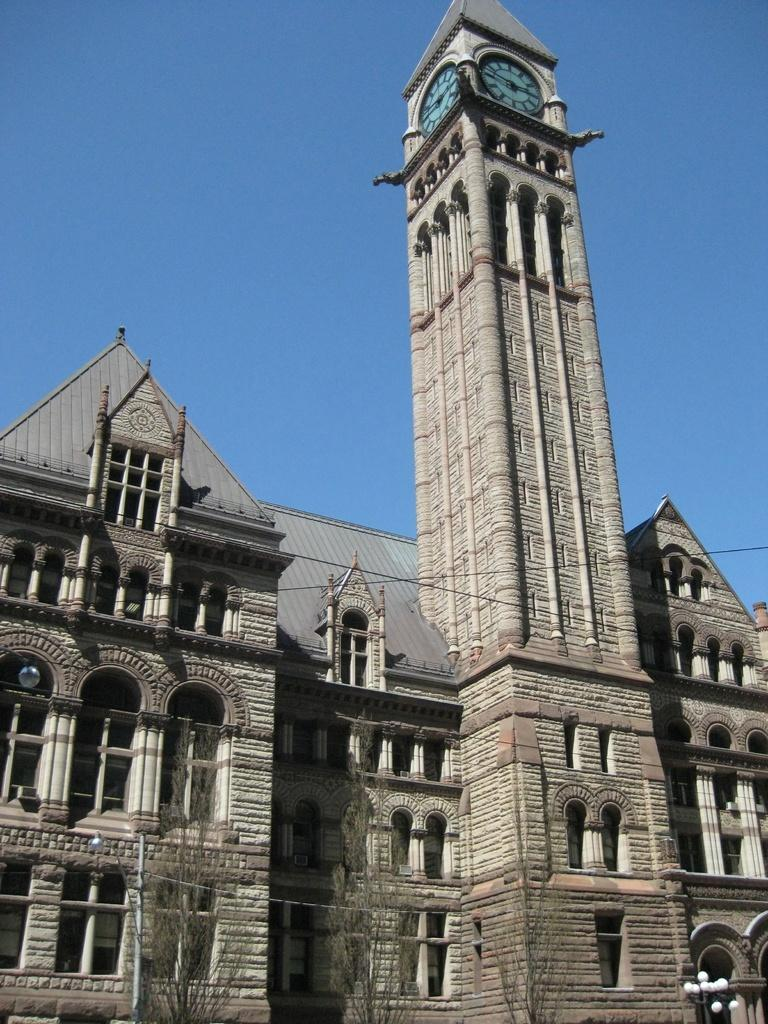How many clocks are visible in the image? There are two clocks on the walls of a tower in the image. What is the relationship between the tower and the building? The tower is attached to a building. What features can be seen on the building? The building has windows and a roof. What is visible in the background of the image? The background of the image includes a blue sky. Can you see any lumber being used in the construction of the building in the image? There is no visible construction or lumber in the image; it shows a completed building with a tower. Is there a basketball court visible in the image? There is no basketball court present in the image. 